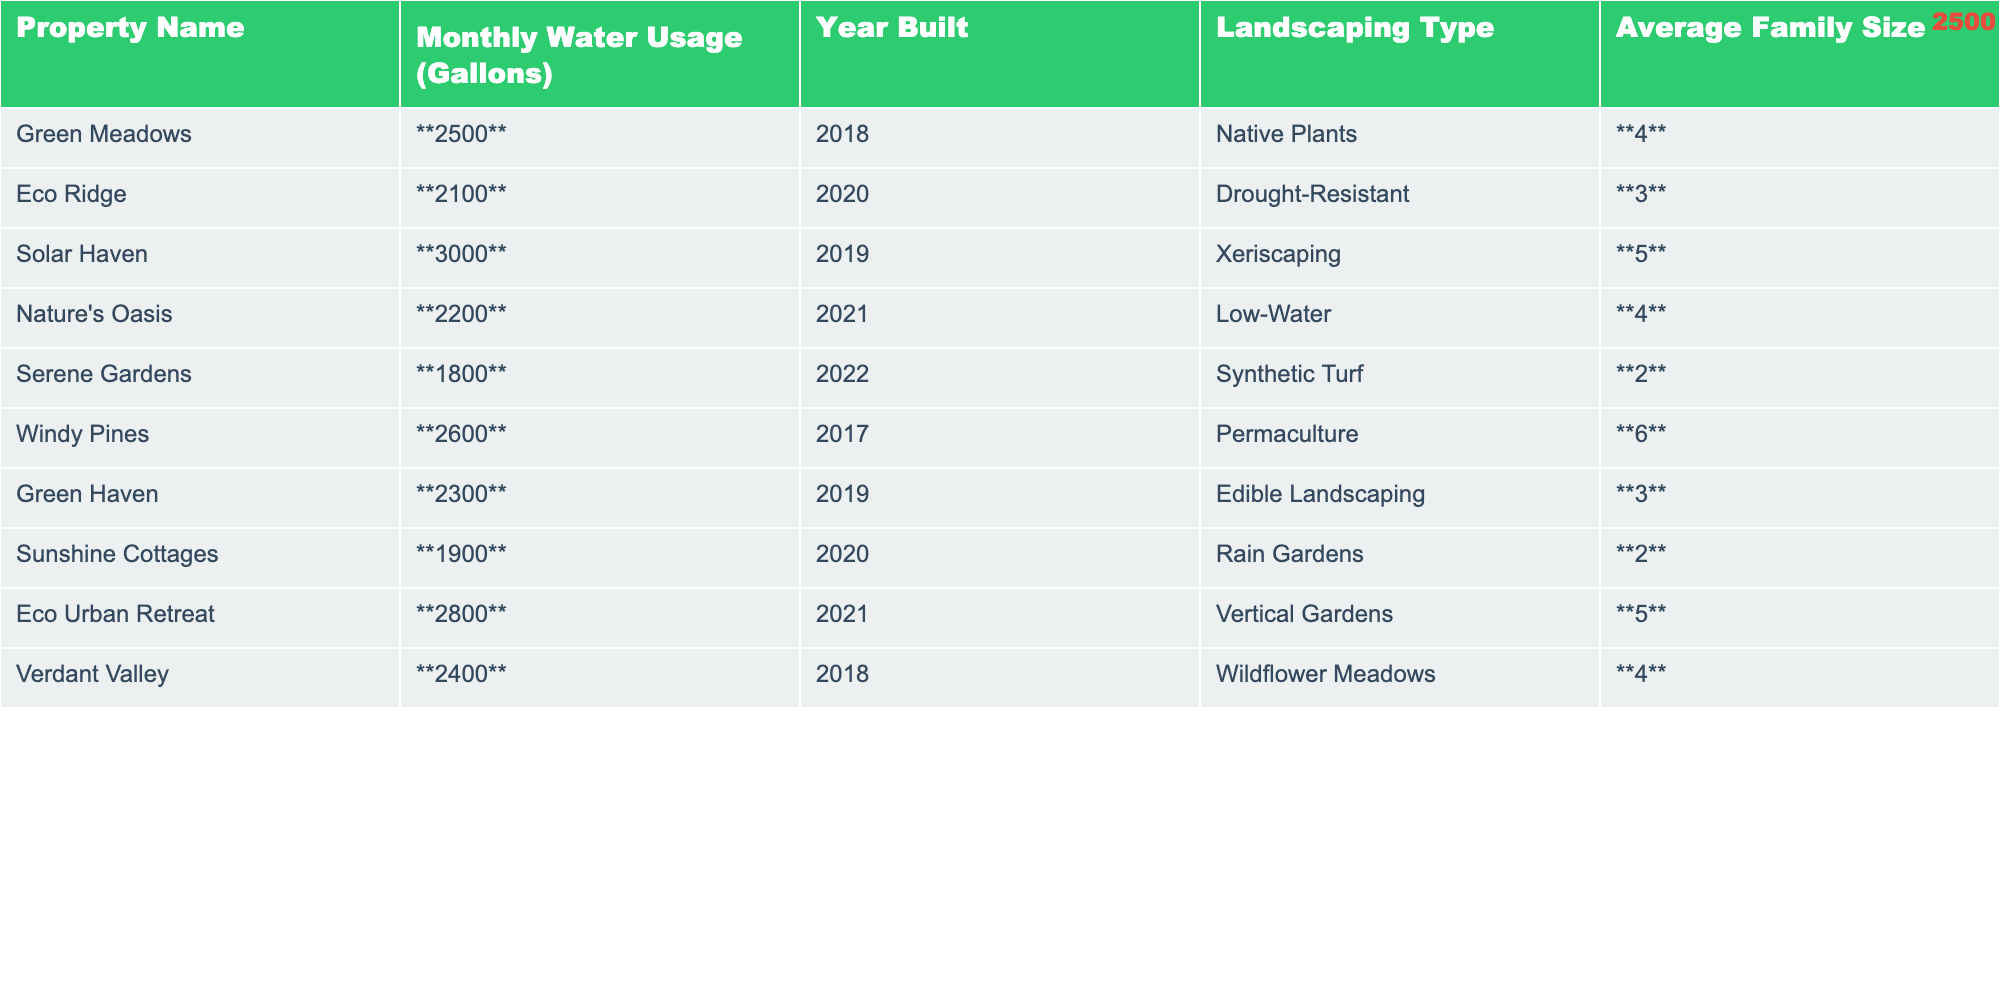What is the monthly water usage of "Windy Pines"? The table shows that the monthly water usage for "Windy Pines" is bolded in the water usage column. The bolded value is **2600** gallons.
Answer: 2600 What landscaping type does "Eco Ridge" use? By looking at the landscaping type column associated with "Eco Ridge", it can be identified that the landscaping type is "Drought-Resistant."
Answer: Drought-Resistant What is the average monthly water usage of all properties? To find the average, we first sum up all the monthly water usage: 2500 + 2100 + 3000 + 2200 + 1800 + 2600 + 2300 + 1900 + 2800 + 2400 =  24600 gallons. Then, we divide by the number of properties (10): 24600 / 10 = 2460 gallons.
Answer: 2460 How many properties have a monthly water usage below 2000 gallons? We examine each property's water usage. Only "Serene Gardens" (1800 gallons) and "Sunshine Cottages" (1900 gallons) have usage below 2000 gallons. Thus, we conclude there are 2 properties.
Answer: 2 Is "Nature's Oasis" built after 2019? The year built for "Nature's Oasis" is 2021, which is after 2019. This confirms that the statement is indeed true.
Answer: Yes Which property has the highest water usage and what is the amount? By reviewing the monthly water usages listed, "Solar Haven" has the highest value at **3000** gallons.
Answer: Solar Haven, 3000 What is the difference in monthly water usage between "Green Meadows" and "Eco Urban Retreat"? "Green Meadows" uses 2500 gallons and "Eco Urban Retreat" uses 2800 gallons. We compute the difference: 2800 - 2500 = 300 gallons.
Answer: 300 How many properties have an average family size of 4 or more? We check the average family size column for values 4 and above. "Green Meadows," "Solar Haven," "Nature's Oasis," "Windy Pines," and "Verdant Valley" meet this criterion, totaling 5 properties.
Answer: 5 Which landscaping type is most frequently used among the listed properties? Reviewing the landscaping types, "Low-Water," "Drought-Resistant," and "Native Plants" each appear once. "Permaculture" and "Edible Landscaping" also appear once while "Synthetic Turf" and "Rain Gardens" appear once. Each can be seen to only occur once. Thus, no dominant type exists.
Answer: No dominant type What is the total monthly water usage of properties with a landscaping type that includes "Gardens"? The properties with "Gardens" are "Eco Urban Retreat" (2800 gallons) and "Sunshine Cottages" (1900 gallons). We sum these for totals: 2800 + 1900 = 4700 gallons.
Answer: 4700 